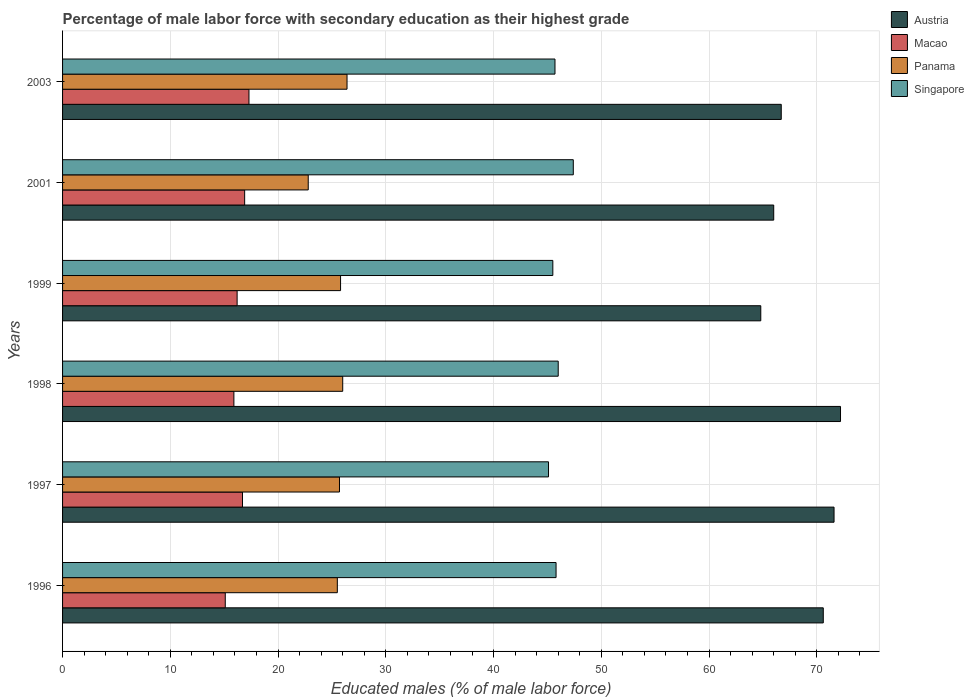Are the number of bars per tick equal to the number of legend labels?
Offer a terse response. Yes. What is the label of the 6th group of bars from the top?
Offer a very short reply. 1996. In how many cases, is the number of bars for a given year not equal to the number of legend labels?
Provide a short and direct response. 0. What is the percentage of male labor force with secondary education in Panama in 1999?
Keep it short and to the point. 25.8. Across all years, what is the maximum percentage of male labor force with secondary education in Panama?
Keep it short and to the point. 26.4. Across all years, what is the minimum percentage of male labor force with secondary education in Austria?
Make the answer very short. 64.8. In which year was the percentage of male labor force with secondary education in Panama maximum?
Keep it short and to the point. 2003. In which year was the percentage of male labor force with secondary education in Singapore minimum?
Your response must be concise. 1997. What is the total percentage of male labor force with secondary education in Macao in the graph?
Offer a terse response. 98.1. What is the difference between the percentage of male labor force with secondary education in Panama in 1996 and that in 2001?
Your answer should be very brief. 2.7. What is the difference between the percentage of male labor force with secondary education in Panama in 1996 and the percentage of male labor force with secondary education in Austria in 1997?
Make the answer very short. -46.1. What is the average percentage of male labor force with secondary education in Panama per year?
Your response must be concise. 25.37. In the year 1997, what is the difference between the percentage of male labor force with secondary education in Macao and percentage of male labor force with secondary education in Austria?
Offer a terse response. -54.9. In how many years, is the percentage of male labor force with secondary education in Panama greater than 38 %?
Your response must be concise. 0. What is the ratio of the percentage of male labor force with secondary education in Panama in 1998 to that in 2003?
Provide a short and direct response. 0.98. Is the percentage of male labor force with secondary education in Austria in 1999 less than that in 2001?
Offer a very short reply. Yes. What is the difference between the highest and the second highest percentage of male labor force with secondary education in Panama?
Keep it short and to the point. 0.4. What is the difference between the highest and the lowest percentage of male labor force with secondary education in Macao?
Offer a very short reply. 2.2. Is it the case that in every year, the sum of the percentage of male labor force with secondary education in Panama and percentage of male labor force with secondary education in Singapore is greater than the sum of percentage of male labor force with secondary education in Austria and percentage of male labor force with secondary education in Macao?
Provide a short and direct response. No. What does the 1st bar from the top in 1999 represents?
Make the answer very short. Singapore. What does the 3rd bar from the bottom in 1999 represents?
Keep it short and to the point. Panama. Is it the case that in every year, the sum of the percentage of male labor force with secondary education in Panama and percentage of male labor force with secondary education in Singapore is greater than the percentage of male labor force with secondary education in Austria?
Offer a terse response. No. How many bars are there?
Your response must be concise. 24. How many years are there in the graph?
Ensure brevity in your answer.  6. Does the graph contain any zero values?
Give a very brief answer. No. Does the graph contain grids?
Your response must be concise. Yes. What is the title of the graph?
Ensure brevity in your answer.  Percentage of male labor force with secondary education as their highest grade. Does "Lower middle income" appear as one of the legend labels in the graph?
Ensure brevity in your answer.  No. What is the label or title of the X-axis?
Offer a terse response. Educated males (% of male labor force). What is the Educated males (% of male labor force) of Austria in 1996?
Keep it short and to the point. 70.6. What is the Educated males (% of male labor force) in Macao in 1996?
Provide a succinct answer. 15.1. What is the Educated males (% of male labor force) of Panama in 1996?
Keep it short and to the point. 25.5. What is the Educated males (% of male labor force) in Singapore in 1996?
Ensure brevity in your answer.  45.8. What is the Educated males (% of male labor force) in Austria in 1997?
Your answer should be compact. 71.6. What is the Educated males (% of male labor force) in Macao in 1997?
Your answer should be compact. 16.7. What is the Educated males (% of male labor force) of Panama in 1997?
Your answer should be compact. 25.7. What is the Educated males (% of male labor force) in Singapore in 1997?
Make the answer very short. 45.1. What is the Educated males (% of male labor force) of Austria in 1998?
Your answer should be compact. 72.2. What is the Educated males (% of male labor force) of Macao in 1998?
Provide a succinct answer. 15.9. What is the Educated males (% of male labor force) of Panama in 1998?
Your response must be concise. 26. What is the Educated males (% of male labor force) in Singapore in 1998?
Ensure brevity in your answer.  46. What is the Educated males (% of male labor force) of Austria in 1999?
Provide a short and direct response. 64.8. What is the Educated males (% of male labor force) of Macao in 1999?
Your answer should be compact. 16.2. What is the Educated males (% of male labor force) of Panama in 1999?
Your answer should be compact. 25.8. What is the Educated males (% of male labor force) in Singapore in 1999?
Your answer should be very brief. 45.5. What is the Educated males (% of male labor force) of Austria in 2001?
Give a very brief answer. 66. What is the Educated males (% of male labor force) in Macao in 2001?
Provide a short and direct response. 16.9. What is the Educated males (% of male labor force) in Panama in 2001?
Give a very brief answer. 22.8. What is the Educated males (% of male labor force) of Singapore in 2001?
Ensure brevity in your answer.  47.4. What is the Educated males (% of male labor force) of Austria in 2003?
Ensure brevity in your answer.  66.7. What is the Educated males (% of male labor force) of Macao in 2003?
Give a very brief answer. 17.3. What is the Educated males (% of male labor force) of Panama in 2003?
Your response must be concise. 26.4. What is the Educated males (% of male labor force) in Singapore in 2003?
Provide a short and direct response. 45.7. Across all years, what is the maximum Educated males (% of male labor force) of Austria?
Ensure brevity in your answer.  72.2. Across all years, what is the maximum Educated males (% of male labor force) in Macao?
Your answer should be very brief. 17.3. Across all years, what is the maximum Educated males (% of male labor force) in Panama?
Make the answer very short. 26.4. Across all years, what is the maximum Educated males (% of male labor force) of Singapore?
Keep it short and to the point. 47.4. Across all years, what is the minimum Educated males (% of male labor force) in Austria?
Provide a succinct answer. 64.8. Across all years, what is the minimum Educated males (% of male labor force) in Macao?
Ensure brevity in your answer.  15.1. Across all years, what is the minimum Educated males (% of male labor force) of Panama?
Ensure brevity in your answer.  22.8. Across all years, what is the minimum Educated males (% of male labor force) of Singapore?
Give a very brief answer. 45.1. What is the total Educated males (% of male labor force) of Austria in the graph?
Give a very brief answer. 411.9. What is the total Educated males (% of male labor force) in Macao in the graph?
Your answer should be compact. 98.1. What is the total Educated males (% of male labor force) of Panama in the graph?
Your answer should be compact. 152.2. What is the total Educated males (% of male labor force) of Singapore in the graph?
Ensure brevity in your answer.  275.5. What is the difference between the Educated males (% of male labor force) of Macao in 1996 and that in 1997?
Offer a very short reply. -1.6. What is the difference between the Educated males (% of male labor force) of Panama in 1996 and that in 1997?
Make the answer very short. -0.2. What is the difference between the Educated males (% of male labor force) of Austria in 1996 and that in 1999?
Your answer should be compact. 5.8. What is the difference between the Educated males (% of male labor force) in Macao in 1996 and that in 1999?
Provide a short and direct response. -1.1. What is the difference between the Educated males (% of male labor force) of Singapore in 1996 and that in 1999?
Provide a succinct answer. 0.3. What is the difference between the Educated males (% of male labor force) in Austria in 1996 and that in 2001?
Offer a terse response. 4.6. What is the difference between the Educated males (% of male labor force) of Panama in 1996 and that in 2001?
Give a very brief answer. 2.7. What is the difference between the Educated males (% of male labor force) of Singapore in 1996 and that in 2001?
Make the answer very short. -1.6. What is the difference between the Educated males (% of male labor force) of Austria in 1996 and that in 2003?
Your response must be concise. 3.9. What is the difference between the Educated males (% of male labor force) of Singapore in 1997 and that in 1998?
Make the answer very short. -0.9. What is the difference between the Educated males (% of male labor force) of Austria in 1997 and that in 1999?
Your answer should be very brief. 6.8. What is the difference between the Educated males (% of male labor force) in Singapore in 1997 and that in 1999?
Offer a very short reply. -0.4. What is the difference between the Educated males (% of male labor force) of Panama in 1997 and that in 2001?
Ensure brevity in your answer.  2.9. What is the difference between the Educated males (% of male labor force) in Singapore in 1998 and that in 1999?
Offer a terse response. 0.5. What is the difference between the Educated males (% of male labor force) of Austria in 1998 and that in 2001?
Provide a short and direct response. 6.2. What is the difference between the Educated males (% of male labor force) of Macao in 1998 and that in 2001?
Offer a terse response. -1. What is the difference between the Educated males (% of male labor force) in Panama in 1998 and that in 2001?
Keep it short and to the point. 3.2. What is the difference between the Educated males (% of male labor force) of Singapore in 1998 and that in 2001?
Offer a terse response. -1.4. What is the difference between the Educated males (% of male labor force) in Macao in 1998 and that in 2003?
Your response must be concise. -1.4. What is the difference between the Educated males (% of male labor force) of Panama in 1998 and that in 2003?
Provide a short and direct response. -0.4. What is the difference between the Educated males (% of male labor force) of Austria in 1999 and that in 2001?
Offer a terse response. -1.2. What is the difference between the Educated males (% of male labor force) of Singapore in 1999 and that in 2001?
Give a very brief answer. -1.9. What is the difference between the Educated males (% of male labor force) in Austria in 2001 and that in 2003?
Your answer should be compact. -0.7. What is the difference between the Educated males (% of male labor force) of Austria in 1996 and the Educated males (% of male labor force) of Macao in 1997?
Offer a terse response. 53.9. What is the difference between the Educated males (% of male labor force) of Austria in 1996 and the Educated males (% of male labor force) of Panama in 1997?
Make the answer very short. 44.9. What is the difference between the Educated males (% of male labor force) of Austria in 1996 and the Educated males (% of male labor force) of Singapore in 1997?
Your answer should be very brief. 25.5. What is the difference between the Educated males (% of male labor force) in Panama in 1996 and the Educated males (% of male labor force) in Singapore in 1997?
Offer a very short reply. -19.6. What is the difference between the Educated males (% of male labor force) in Austria in 1996 and the Educated males (% of male labor force) in Macao in 1998?
Offer a terse response. 54.7. What is the difference between the Educated males (% of male labor force) in Austria in 1996 and the Educated males (% of male labor force) in Panama in 1998?
Offer a very short reply. 44.6. What is the difference between the Educated males (% of male labor force) of Austria in 1996 and the Educated males (% of male labor force) of Singapore in 1998?
Ensure brevity in your answer.  24.6. What is the difference between the Educated males (% of male labor force) of Macao in 1996 and the Educated males (% of male labor force) of Singapore in 1998?
Provide a short and direct response. -30.9. What is the difference between the Educated males (% of male labor force) of Panama in 1996 and the Educated males (% of male labor force) of Singapore in 1998?
Your answer should be compact. -20.5. What is the difference between the Educated males (% of male labor force) of Austria in 1996 and the Educated males (% of male labor force) of Macao in 1999?
Offer a very short reply. 54.4. What is the difference between the Educated males (% of male labor force) of Austria in 1996 and the Educated males (% of male labor force) of Panama in 1999?
Provide a succinct answer. 44.8. What is the difference between the Educated males (% of male labor force) of Austria in 1996 and the Educated males (% of male labor force) of Singapore in 1999?
Your response must be concise. 25.1. What is the difference between the Educated males (% of male labor force) of Macao in 1996 and the Educated males (% of male labor force) of Panama in 1999?
Your answer should be very brief. -10.7. What is the difference between the Educated males (% of male labor force) of Macao in 1996 and the Educated males (% of male labor force) of Singapore in 1999?
Your answer should be very brief. -30.4. What is the difference between the Educated males (% of male labor force) in Austria in 1996 and the Educated males (% of male labor force) in Macao in 2001?
Give a very brief answer. 53.7. What is the difference between the Educated males (% of male labor force) of Austria in 1996 and the Educated males (% of male labor force) of Panama in 2001?
Your answer should be very brief. 47.8. What is the difference between the Educated males (% of male labor force) of Austria in 1996 and the Educated males (% of male labor force) of Singapore in 2001?
Keep it short and to the point. 23.2. What is the difference between the Educated males (% of male labor force) in Macao in 1996 and the Educated males (% of male labor force) in Singapore in 2001?
Provide a succinct answer. -32.3. What is the difference between the Educated males (% of male labor force) in Panama in 1996 and the Educated males (% of male labor force) in Singapore in 2001?
Give a very brief answer. -21.9. What is the difference between the Educated males (% of male labor force) in Austria in 1996 and the Educated males (% of male labor force) in Macao in 2003?
Give a very brief answer. 53.3. What is the difference between the Educated males (% of male labor force) of Austria in 1996 and the Educated males (% of male labor force) of Panama in 2003?
Offer a terse response. 44.2. What is the difference between the Educated males (% of male labor force) in Austria in 1996 and the Educated males (% of male labor force) in Singapore in 2003?
Your answer should be very brief. 24.9. What is the difference between the Educated males (% of male labor force) of Macao in 1996 and the Educated males (% of male labor force) of Panama in 2003?
Provide a succinct answer. -11.3. What is the difference between the Educated males (% of male labor force) in Macao in 1996 and the Educated males (% of male labor force) in Singapore in 2003?
Your answer should be very brief. -30.6. What is the difference between the Educated males (% of male labor force) of Panama in 1996 and the Educated males (% of male labor force) of Singapore in 2003?
Ensure brevity in your answer.  -20.2. What is the difference between the Educated males (% of male labor force) of Austria in 1997 and the Educated males (% of male labor force) of Macao in 1998?
Your response must be concise. 55.7. What is the difference between the Educated males (% of male labor force) of Austria in 1997 and the Educated males (% of male labor force) of Panama in 1998?
Provide a succinct answer. 45.6. What is the difference between the Educated males (% of male labor force) of Austria in 1997 and the Educated males (% of male labor force) of Singapore in 1998?
Your answer should be compact. 25.6. What is the difference between the Educated males (% of male labor force) of Macao in 1997 and the Educated males (% of male labor force) of Panama in 1998?
Your answer should be very brief. -9.3. What is the difference between the Educated males (% of male labor force) in Macao in 1997 and the Educated males (% of male labor force) in Singapore in 1998?
Give a very brief answer. -29.3. What is the difference between the Educated males (% of male labor force) in Panama in 1997 and the Educated males (% of male labor force) in Singapore in 1998?
Give a very brief answer. -20.3. What is the difference between the Educated males (% of male labor force) in Austria in 1997 and the Educated males (% of male labor force) in Macao in 1999?
Make the answer very short. 55.4. What is the difference between the Educated males (% of male labor force) of Austria in 1997 and the Educated males (% of male labor force) of Panama in 1999?
Provide a succinct answer. 45.8. What is the difference between the Educated males (% of male labor force) of Austria in 1997 and the Educated males (% of male labor force) of Singapore in 1999?
Ensure brevity in your answer.  26.1. What is the difference between the Educated males (% of male labor force) of Macao in 1997 and the Educated males (% of male labor force) of Panama in 1999?
Your response must be concise. -9.1. What is the difference between the Educated males (% of male labor force) in Macao in 1997 and the Educated males (% of male labor force) in Singapore in 1999?
Ensure brevity in your answer.  -28.8. What is the difference between the Educated males (% of male labor force) in Panama in 1997 and the Educated males (% of male labor force) in Singapore in 1999?
Give a very brief answer. -19.8. What is the difference between the Educated males (% of male labor force) of Austria in 1997 and the Educated males (% of male labor force) of Macao in 2001?
Give a very brief answer. 54.7. What is the difference between the Educated males (% of male labor force) of Austria in 1997 and the Educated males (% of male labor force) of Panama in 2001?
Keep it short and to the point. 48.8. What is the difference between the Educated males (% of male labor force) in Austria in 1997 and the Educated males (% of male labor force) in Singapore in 2001?
Ensure brevity in your answer.  24.2. What is the difference between the Educated males (% of male labor force) of Macao in 1997 and the Educated males (% of male labor force) of Panama in 2001?
Offer a terse response. -6.1. What is the difference between the Educated males (% of male labor force) in Macao in 1997 and the Educated males (% of male labor force) in Singapore in 2001?
Your answer should be compact. -30.7. What is the difference between the Educated males (% of male labor force) in Panama in 1997 and the Educated males (% of male labor force) in Singapore in 2001?
Provide a short and direct response. -21.7. What is the difference between the Educated males (% of male labor force) of Austria in 1997 and the Educated males (% of male labor force) of Macao in 2003?
Keep it short and to the point. 54.3. What is the difference between the Educated males (% of male labor force) of Austria in 1997 and the Educated males (% of male labor force) of Panama in 2003?
Keep it short and to the point. 45.2. What is the difference between the Educated males (% of male labor force) in Austria in 1997 and the Educated males (% of male labor force) in Singapore in 2003?
Offer a terse response. 25.9. What is the difference between the Educated males (% of male labor force) in Austria in 1998 and the Educated males (% of male labor force) in Panama in 1999?
Ensure brevity in your answer.  46.4. What is the difference between the Educated males (% of male labor force) of Austria in 1998 and the Educated males (% of male labor force) of Singapore in 1999?
Your response must be concise. 26.7. What is the difference between the Educated males (% of male labor force) in Macao in 1998 and the Educated males (% of male labor force) in Panama in 1999?
Provide a short and direct response. -9.9. What is the difference between the Educated males (% of male labor force) of Macao in 1998 and the Educated males (% of male labor force) of Singapore in 1999?
Ensure brevity in your answer.  -29.6. What is the difference between the Educated males (% of male labor force) of Panama in 1998 and the Educated males (% of male labor force) of Singapore in 1999?
Offer a very short reply. -19.5. What is the difference between the Educated males (% of male labor force) in Austria in 1998 and the Educated males (% of male labor force) in Macao in 2001?
Ensure brevity in your answer.  55.3. What is the difference between the Educated males (% of male labor force) in Austria in 1998 and the Educated males (% of male labor force) in Panama in 2001?
Your answer should be very brief. 49.4. What is the difference between the Educated males (% of male labor force) of Austria in 1998 and the Educated males (% of male labor force) of Singapore in 2001?
Provide a succinct answer. 24.8. What is the difference between the Educated males (% of male labor force) in Macao in 1998 and the Educated males (% of male labor force) in Singapore in 2001?
Make the answer very short. -31.5. What is the difference between the Educated males (% of male labor force) in Panama in 1998 and the Educated males (% of male labor force) in Singapore in 2001?
Your answer should be compact. -21.4. What is the difference between the Educated males (% of male labor force) in Austria in 1998 and the Educated males (% of male labor force) in Macao in 2003?
Make the answer very short. 54.9. What is the difference between the Educated males (% of male labor force) of Austria in 1998 and the Educated males (% of male labor force) of Panama in 2003?
Offer a very short reply. 45.8. What is the difference between the Educated males (% of male labor force) of Macao in 1998 and the Educated males (% of male labor force) of Singapore in 2003?
Offer a very short reply. -29.8. What is the difference between the Educated males (% of male labor force) in Panama in 1998 and the Educated males (% of male labor force) in Singapore in 2003?
Provide a succinct answer. -19.7. What is the difference between the Educated males (% of male labor force) of Austria in 1999 and the Educated males (% of male labor force) of Macao in 2001?
Your answer should be compact. 47.9. What is the difference between the Educated males (% of male labor force) in Macao in 1999 and the Educated males (% of male labor force) in Panama in 2001?
Provide a short and direct response. -6.6. What is the difference between the Educated males (% of male labor force) of Macao in 1999 and the Educated males (% of male labor force) of Singapore in 2001?
Provide a succinct answer. -31.2. What is the difference between the Educated males (% of male labor force) in Panama in 1999 and the Educated males (% of male labor force) in Singapore in 2001?
Your answer should be very brief. -21.6. What is the difference between the Educated males (% of male labor force) of Austria in 1999 and the Educated males (% of male labor force) of Macao in 2003?
Ensure brevity in your answer.  47.5. What is the difference between the Educated males (% of male labor force) of Austria in 1999 and the Educated males (% of male labor force) of Panama in 2003?
Your answer should be compact. 38.4. What is the difference between the Educated males (% of male labor force) of Austria in 1999 and the Educated males (% of male labor force) of Singapore in 2003?
Give a very brief answer. 19.1. What is the difference between the Educated males (% of male labor force) of Macao in 1999 and the Educated males (% of male labor force) of Panama in 2003?
Give a very brief answer. -10.2. What is the difference between the Educated males (% of male labor force) of Macao in 1999 and the Educated males (% of male labor force) of Singapore in 2003?
Make the answer very short. -29.5. What is the difference between the Educated males (% of male labor force) in Panama in 1999 and the Educated males (% of male labor force) in Singapore in 2003?
Your answer should be very brief. -19.9. What is the difference between the Educated males (% of male labor force) of Austria in 2001 and the Educated males (% of male labor force) of Macao in 2003?
Offer a very short reply. 48.7. What is the difference between the Educated males (% of male labor force) of Austria in 2001 and the Educated males (% of male labor force) of Panama in 2003?
Give a very brief answer. 39.6. What is the difference between the Educated males (% of male labor force) in Austria in 2001 and the Educated males (% of male labor force) in Singapore in 2003?
Offer a very short reply. 20.3. What is the difference between the Educated males (% of male labor force) in Macao in 2001 and the Educated males (% of male labor force) in Singapore in 2003?
Your response must be concise. -28.8. What is the difference between the Educated males (% of male labor force) of Panama in 2001 and the Educated males (% of male labor force) of Singapore in 2003?
Make the answer very short. -22.9. What is the average Educated males (% of male labor force) in Austria per year?
Provide a short and direct response. 68.65. What is the average Educated males (% of male labor force) of Macao per year?
Make the answer very short. 16.35. What is the average Educated males (% of male labor force) in Panama per year?
Offer a terse response. 25.37. What is the average Educated males (% of male labor force) in Singapore per year?
Give a very brief answer. 45.92. In the year 1996, what is the difference between the Educated males (% of male labor force) in Austria and Educated males (% of male labor force) in Macao?
Make the answer very short. 55.5. In the year 1996, what is the difference between the Educated males (% of male labor force) of Austria and Educated males (% of male labor force) of Panama?
Ensure brevity in your answer.  45.1. In the year 1996, what is the difference between the Educated males (% of male labor force) in Austria and Educated males (% of male labor force) in Singapore?
Ensure brevity in your answer.  24.8. In the year 1996, what is the difference between the Educated males (% of male labor force) of Macao and Educated males (% of male labor force) of Panama?
Your response must be concise. -10.4. In the year 1996, what is the difference between the Educated males (% of male labor force) in Macao and Educated males (% of male labor force) in Singapore?
Provide a short and direct response. -30.7. In the year 1996, what is the difference between the Educated males (% of male labor force) of Panama and Educated males (% of male labor force) of Singapore?
Offer a terse response. -20.3. In the year 1997, what is the difference between the Educated males (% of male labor force) in Austria and Educated males (% of male labor force) in Macao?
Your answer should be compact. 54.9. In the year 1997, what is the difference between the Educated males (% of male labor force) in Austria and Educated males (% of male labor force) in Panama?
Offer a very short reply. 45.9. In the year 1997, what is the difference between the Educated males (% of male labor force) in Austria and Educated males (% of male labor force) in Singapore?
Keep it short and to the point. 26.5. In the year 1997, what is the difference between the Educated males (% of male labor force) in Macao and Educated males (% of male labor force) in Singapore?
Provide a short and direct response. -28.4. In the year 1997, what is the difference between the Educated males (% of male labor force) in Panama and Educated males (% of male labor force) in Singapore?
Keep it short and to the point. -19.4. In the year 1998, what is the difference between the Educated males (% of male labor force) of Austria and Educated males (% of male labor force) of Macao?
Make the answer very short. 56.3. In the year 1998, what is the difference between the Educated males (% of male labor force) in Austria and Educated males (% of male labor force) in Panama?
Offer a very short reply. 46.2. In the year 1998, what is the difference between the Educated males (% of male labor force) in Austria and Educated males (% of male labor force) in Singapore?
Ensure brevity in your answer.  26.2. In the year 1998, what is the difference between the Educated males (% of male labor force) in Macao and Educated males (% of male labor force) in Panama?
Make the answer very short. -10.1. In the year 1998, what is the difference between the Educated males (% of male labor force) in Macao and Educated males (% of male labor force) in Singapore?
Your answer should be compact. -30.1. In the year 1998, what is the difference between the Educated males (% of male labor force) in Panama and Educated males (% of male labor force) in Singapore?
Offer a terse response. -20. In the year 1999, what is the difference between the Educated males (% of male labor force) in Austria and Educated males (% of male labor force) in Macao?
Your response must be concise. 48.6. In the year 1999, what is the difference between the Educated males (% of male labor force) in Austria and Educated males (% of male labor force) in Panama?
Make the answer very short. 39. In the year 1999, what is the difference between the Educated males (% of male labor force) in Austria and Educated males (% of male labor force) in Singapore?
Your response must be concise. 19.3. In the year 1999, what is the difference between the Educated males (% of male labor force) of Macao and Educated males (% of male labor force) of Singapore?
Your response must be concise. -29.3. In the year 1999, what is the difference between the Educated males (% of male labor force) in Panama and Educated males (% of male labor force) in Singapore?
Ensure brevity in your answer.  -19.7. In the year 2001, what is the difference between the Educated males (% of male labor force) of Austria and Educated males (% of male labor force) of Macao?
Make the answer very short. 49.1. In the year 2001, what is the difference between the Educated males (% of male labor force) in Austria and Educated males (% of male labor force) in Panama?
Keep it short and to the point. 43.2. In the year 2001, what is the difference between the Educated males (% of male labor force) of Macao and Educated males (% of male labor force) of Panama?
Offer a very short reply. -5.9. In the year 2001, what is the difference between the Educated males (% of male labor force) of Macao and Educated males (% of male labor force) of Singapore?
Provide a short and direct response. -30.5. In the year 2001, what is the difference between the Educated males (% of male labor force) in Panama and Educated males (% of male labor force) in Singapore?
Your answer should be compact. -24.6. In the year 2003, what is the difference between the Educated males (% of male labor force) of Austria and Educated males (% of male labor force) of Macao?
Your response must be concise. 49.4. In the year 2003, what is the difference between the Educated males (% of male labor force) of Austria and Educated males (% of male labor force) of Panama?
Give a very brief answer. 40.3. In the year 2003, what is the difference between the Educated males (% of male labor force) in Macao and Educated males (% of male labor force) in Panama?
Offer a terse response. -9.1. In the year 2003, what is the difference between the Educated males (% of male labor force) of Macao and Educated males (% of male labor force) of Singapore?
Offer a terse response. -28.4. In the year 2003, what is the difference between the Educated males (% of male labor force) of Panama and Educated males (% of male labor force) of Singapore?
Offer a terse response. -19.3. What is the ratio of the Educated males (% of male labor force) in Austria in 1996 to that in 1997?
Your answer should be very brief. 0.99. What is the ratio of the Educated males (% of male labor force) of Macao in 1996 to that in 1997?
Give a very brief answer. 0.9. What is the ratio of the Educated males (% of male labor force) of Singapore in 1996 to that in 1997?
Ensure brevity in your answer.  1.02. What is the ratio of the Educated males (% of male labor force) in Austria in 1996 to that in 1998?
Offer a terse response. 0.98. What is the ratio of the Educated males (% of male labor force) of Macao in 1996 to that in 1998?
Offer a terse response. 0.95. What is the ratio of the Educated males (% of male labor force) in Panama in 1996 to that in 1998?
Provide a short and direct response. 0.98. What is the ratio of the Educated males (% of male labor force) of Singapore in 1996 to that in 1998?
Provide a short and direct response. 1. What is the ratio of the Educated males (% of male labor force) of Austria in 1996 to that in 1999?
Your answer should be compact. 1.09. What is the ratio of the Educated males (% of male labor force) in Macao in 1996 to that in 1999?
Your response must be concise. 0.93. What is the ratio of the Educated males (% of male labor force) in Panama in 1996 to that in 1999?
Your response must be concise. 0.99. What is the ratio of the Educated males (% of male labor force) in Singapore in 1996 to that in 1999?
Keep it short and to the point. 1.01. What is the ratio of the Educated males (% of male labor force) in Austria in 1996 to that in 2001?
Keep it short and to the point. 1.07. What is the ratio of the Educated males (% of male labor force) in Macao in 1996 to that in 2001?
Offer a terse response. 0.89. What is the ratio of the Educated males (% of male labor force) of Panama in 1996 to that in 2001?
Ensure brevity in your answer.  1.12. What is the ratio of the Educated males (% of male labor force) in Singapore in 1996 to that in 2001?
Keep it short and to the point. 0.97. What is the ratio of the Educated males (% of male labor force) in Austria in 1996 to that in 2003?
Provide a short and direct response. 1.06. What is the ratio of the Educated males (% of male labor force) of Macao in 1996 to that in 2003?
Your response must be concise. 0.87. What is the ratio of the Educated males (% of male labor force) of Panama in 1996 to that in 2003?
Your response must be concise. 0.97. What is the ratio of the Educated males (% of male labor force) of Macao in 1997 to that in 1998?
Provide a short and direct response. 1.05. What is the ratio of the Educated males (% of male labor force) in Panama in 1997 to that in 1998?
Your answer should be very brief. 0.99. What is the ratio of the Educated males (% of male labor force) in Singapore in 1997 to that in 1998?
Offer a terse response. 0.98. What is the ratio of the Educated males (% of male labor force) of Austria in 1997 to that in 1999?
Offer a very short reply. 1.1. What is the ratio of the Educated males (% of male labor force) of Macao in 1997 to that in 1999?
Ensure brevity in your answer.  1.03. What is the ratio of the Educated males (% of male labor force) in Singapore in 1997 to that in 1999?
Offer a very short reply. 0.99. What is the ratio of the Educated males (% of male labor force) of Austria in 1997 to that in 2001?
Your answer should be very brief. 1.08. What is the ratio of the Educated males (% of male labor force) of Panama in 1997 to that in 2001?
Your answer should be compact. 1.13. What is the ratio of the Educated males (% of male labor force) of Singapore in 1997 to that in 2001?
Your response must be concise. 0.95. What is the ratio of the Educated males (% of male labor force) of Austria in 1997 to that in 2003?
Make the answer very short. 1.07. What is the ratio of the Educated males (% of male labor force) in Macao in 1997 to that in 2003?
Offer a terse response. 0.97. What is the ratio of the Educated males (% of male labor force) of Panama in 1997 to that in 2003?
Ensure brevity in your answer.  0.97. What is the ratio of the Educated males (% of male labor force) of Singapore in 1997 to that in 2003?
Ensure brevity in your answer.  0.99. What is the ratio of the Educated males (% of male labor force) in Austria in 1998 to that in 1999?
Ensure brevity in your answer.  1.11. What is the ratio of the Educated males (% of male labor force) in Macao in 1998 to that in 1999?
Make the answer very short. 0.98. What is the ratio of the Educated males (% of male labor force) of Panama in 1998 to that in 1999?
Your response must be concise. 1.01. What is the ratio of the Educated males (% of male labor force) in Singapore in 1998 to that in 1999?
Provide a short and direct response. 1.01. What is the ratio of the Educated males (% of male labor force) of Austria in 1998 to that in 2001?
Your answer should be very brief. 1.09. What is the ratio of the Educated males (% of male labor force) in Macao in 1998 to that in 2001?
Keep it short and to the point. 0.94. What is the ratio of the Educated males (% of male labor force) of Panama in 1998 to that in 2001?
Offer a very short reply. 1.14. What is the ratio of the Educated males (% of male labor force) in Singapore in 1998 to that in 2001?
Provide a succinct answer. 0.97. What is the ratio of the Educated males (% of male labor force) of Austria in 1998 to that in 2003?
Ensure brevity in your answer.  1.08. What is the ratio of the Educated males (% of male labor force) of Macao in 1998 to that in 2003?
Ensure brevity in your answer.  0.92. What is the ratio of the Educated males (% of male labor force) in Singapore in 1998 to that in 2003?
Your answer should be very brief. 1.01. What is the ratio of the Educated males (% of male labor force) in Austria in 1999 to that in 2001?
Keep it short and to the point. 0.98. What is the ratio of the Educated males (% of male labor force) of Macao in 1999 to that in 2001?
Your answer should be very brief. 0.96. What is the ratio of the Educated males (% of male labor force) in Panama in 1999 to that in 2001?
Offer a terse response. 1.13. What is the ratio of the Educated males (% of male labor force) in Singapore in 1999 to that in 2001?
Provide a succinct answer. 0.96. What is the ratio of the Educated males (% of male labor force) in Austria in 1999 to that in 2003?
Ensure brevity in your answer.  0.97. What is the ratio of the Educated males (% of male labor force) in Macao in 1999 to that in 2003?
Offer a very short reply. 0.94. What is the ratio of the Educated males (% of male labor force) of Panama in 1999 to that in 2003?
Your answer should be compact. 0.98. What is the ratio of the Educated males (% of male labor force) of Singapore in 1999 to that in 2003?
Provide a short and direct response. 1. What is the ratio of the Educated males (% of male labor force) in Macao in 2001 to that in 2003?
Provide a succinct answer. 0.98. What is the ratio of the Educated males (% of male labor force) of Panama in 2001 to that in 2003?
Offer a very short reply. 0.86. What is the ratio of the Educated males (% of male labor force) of Singapore in 2001 to that in 2003?
Make the answer very short. 1.04. What is the difference between the highest and the second highest Educated males (% of male labor force) in Austria?
Make the answer very short. 0.6. What is the difference between the highest and the second highest Educated males (% of male labor force) of Macao?
Your answer should be compact. 0.4. What is the difference between the highest and the second highest Educated males (% of male labor force) in Panama?
Your response must be concise. 0.4. What is the difference between the highest and the second highest Educated males (% of male labor force) in Singapore?
Offer a very short reply. 1.4. What is the difference between the highest and the lowest Educated males (% of male labor force) of Austria?
Ensure brevity in your answer.  7.4. What is the difference between the highest and the lowest Educated males (% of male labor force) of Macao?
Give a very brief answer. 2.2. 